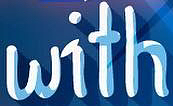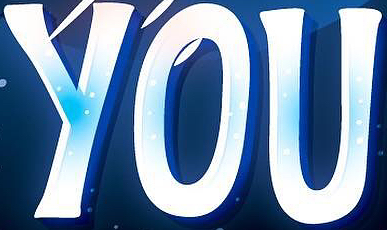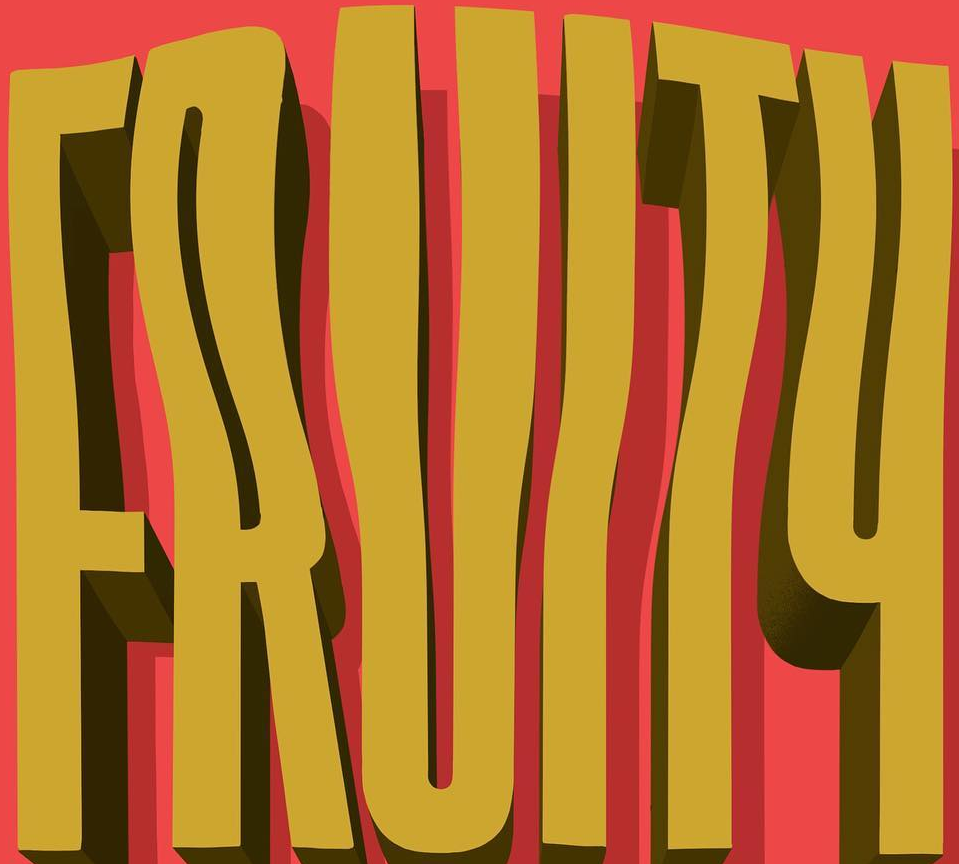What words can you see in these images in sequence, separated by a semicolon? with; YOU; FRUITY 